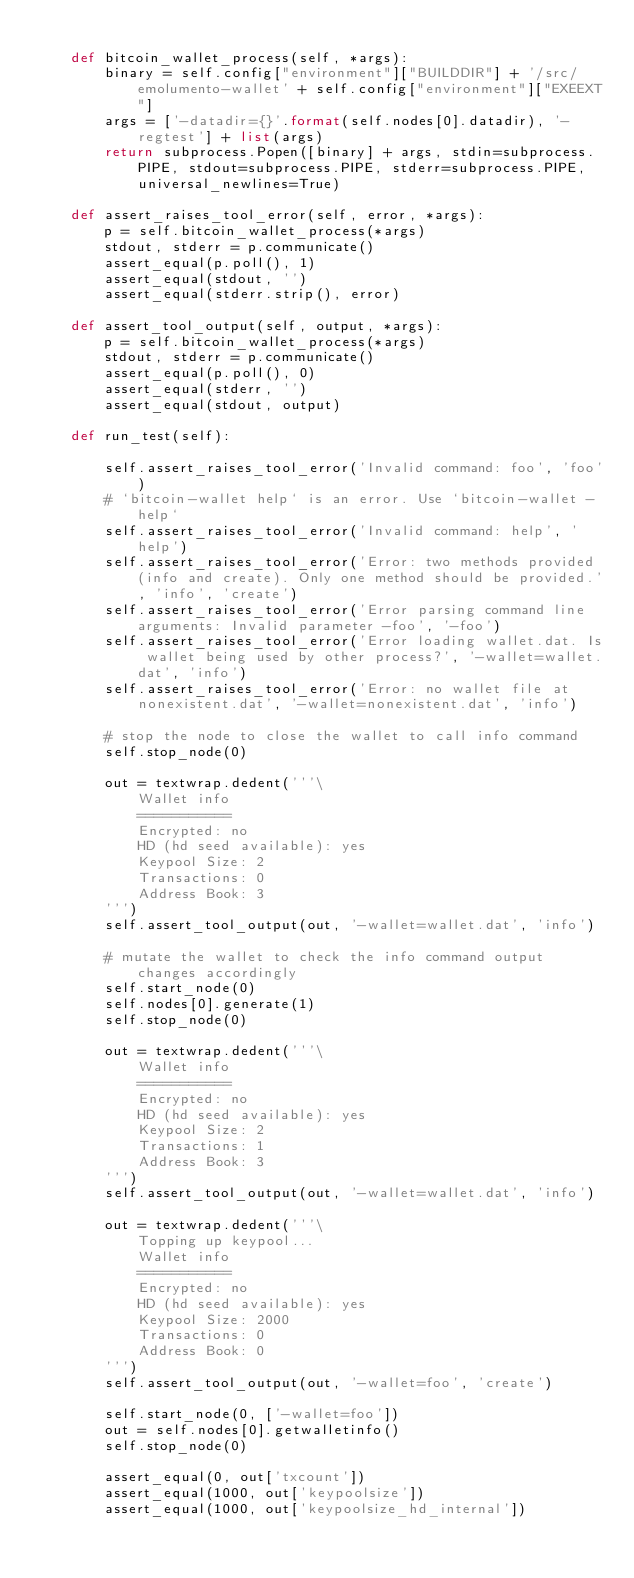<code> <loc_0><loc_0><loc_500><loc_500><_Python_>
    def bitcoin_wallet_process(self, *args):
        binary = self.config["environment"]["BUILDDIR"] + '/src/emolumento-wallet' + self.config["environment"]["EXEEXT"]
        args = ['-datadir={}'.format(self.nodes[0].datadir), '-regtest'] + list(args)
        return subprocess.Popen([binary] + args, stdin=subprocess.PIPE, stdout=subprocess.PIPE, stderr=subprocess.PIPE, universal_newlines=True)

    def assert_raises_tool_error(self, error, *args):
        p = self.bitcoin_wallet_process(*args)
        stdout, stderr = p.communicate()
        assert_equal(p.poll(), 1)
        assert_equal(stdout, '')
        assert_equal(stderr.strip(), error)

    def assert_tool_output(self, output, *args):
        p = self.bitcoin_wallet_process(*args)
        stdout, stderr = p.communicate()
        assert_equal(p.poll(), 0)
        assert_equal(stderr, '')
        assert_equal(stdout, output)

    def run_test(self):

        self.assert_raises_tool_error('Invalid command: foo', 'foo')
        # `bitcoin-wallet help` is an error. Use `bitcoin-wallet -help`
        self.assert_raises_tool_error('Invalid command: help', 'help')
        self.assert_raises_tool_error('Error: two methods provided (info and create). Only one method should be provided.', 'info', 'create')
        self.assert_raises_tool_error('Error parsing command line arguments: Invalid parameter -foo', '-foo')
        self.assert_raises_tool_error('Error loading wallet.dat. Is wallet being used by other process?', '-wallet=wallet.dat', 'info')
        self.assert_raises_tool_error('Error: no wallet file at nonexistent.dat', '-wallet=nonexistent.dat', 'info')

        # stop the node to close the wallet to call info command
        self.stop_node(0)

        out = textwrap.dedent('''\
            Wallet info
            ===========
            Encrypted: no
            HD (hd seed available): yes
            Keypool Size: 2
            Transactions: 0
            Address Book: 3
        ''')
        self.assert_tool_output(out, '-wallet=wallet.dat', 'info')

        # mutate the wallet to check the info command output changes accordingly
        self.start_node(0)
        self.nodes[0].generate(1)
        self.stop_node(0)

        out = textwrap.dedent('''\
            Wallet info
            ===========
            Encrypted: no
            HD (hd seed available): yes
            Keypool Size: 2
            Transactions: 1
            Address Book: 3
        ''')
        self.assert_tool_output(out, '-wallet=wallet.dat', 'info')

        out = textwrap.dedent('''\
            Topping up keypool...
            Wallet info
            ===========
            Encrypted: no
            HD (hd seed available): yes
            Keypool Size: 2000
            Transactions: 0
            Address Book: 0
        ''')
        self.assert_tool_output(out, '-wallet=foo', 'create')

        self.start_node(0, ['-wallet=foo'])
        out = self.nodes[0].getwalletinfo()
        self.stop_node(0)

        assert_equal(0, out['txcount'])
        assert_equal(1000, out['keypoolsize'])
        assert_equal(1000, out['keypoolsize_hd_internal'])</code> 